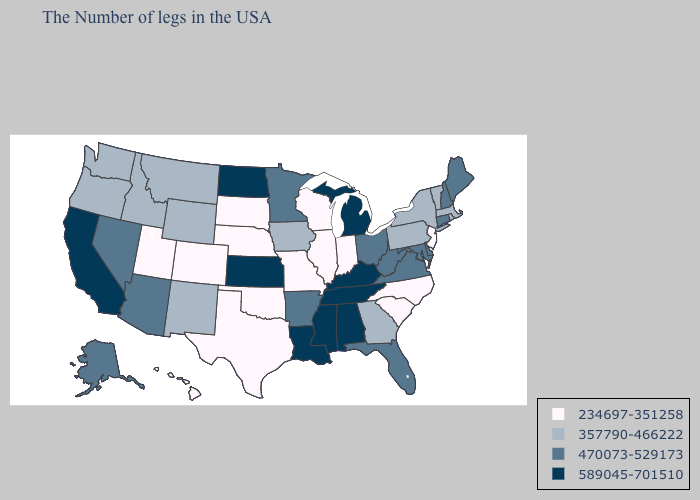Name the states that have a value in the range 470073-529173?
Give a very brief answer. Maine, New Hampshire, Connecticut, Delaware, Maryland, Virginia, West Virginia, Ohio, Florida, Arkansas, Minnesota, Arizona, Nevada, Alaska. Does Minnesota have the same value as Florida?
Quick response, please. Yes. Name the states that have a value in the range 470073-529173?
Be succinct. Maine, New Hampshire, Connecticut, Delaware, Maryland, Virginia, West Virginia, Ohio, Florida, Arkansas, Minnesota, Arizona, Nevada, Alaska. Does Virginia have the lowest value in the South?
Give a very brief answer. No. Does the map have missing data?
Keep it brief. No. Among the states that border Delaware , does Maryland have the highest value?
Be succinct. Yes. What is the value of New Mexico?
Keep it brief. 357790-466222. What is the lowest value in the South?
Write a very short answer. 234697-351258. Name the states that have a value in the range 589045-701510?
Give a very brief answer. Michigan, Kentucky, Alabama, Tennessee, Mississippi, Louisiana, Kansas, North Dakota, California. What is the lowest value in states that border South Carolina?
Keep it brief. 234697-351258. Which states have the lowest value in the USA?
Concise answer only. New Jersey, North Carolina, South Carolina, Indiana, Wisconsin, Illinois, Missouri, Nebraska, Oklahoma, Texas, South Dakota, Colorado, Utah, Hawaii. Does Maine have a higher value than North Dakota?
Short answer required. No. Name the states that have a value in the range 589045-701510?
Write a very short answer. Michigan, Kentucky, Alabama, Tennessee, Mississippi, Louisiana, Kansas, North Dakota, California. Name the states that have a value in the range 357790-466222?
Answer briefly. Massachusetts, Rhode Island, Vermont, New York, Pennsylvania, Georgia, Iowa, Wyoming, New Mexico, Montana, Idaho, Washington, Oregon. Name the states that have a value in the range 589045-701510?
Be succinct. Michigan, Kentucky, Alabama, Tennessee, Mississippi, Louisiana, Kansas, North Dakota, California. 